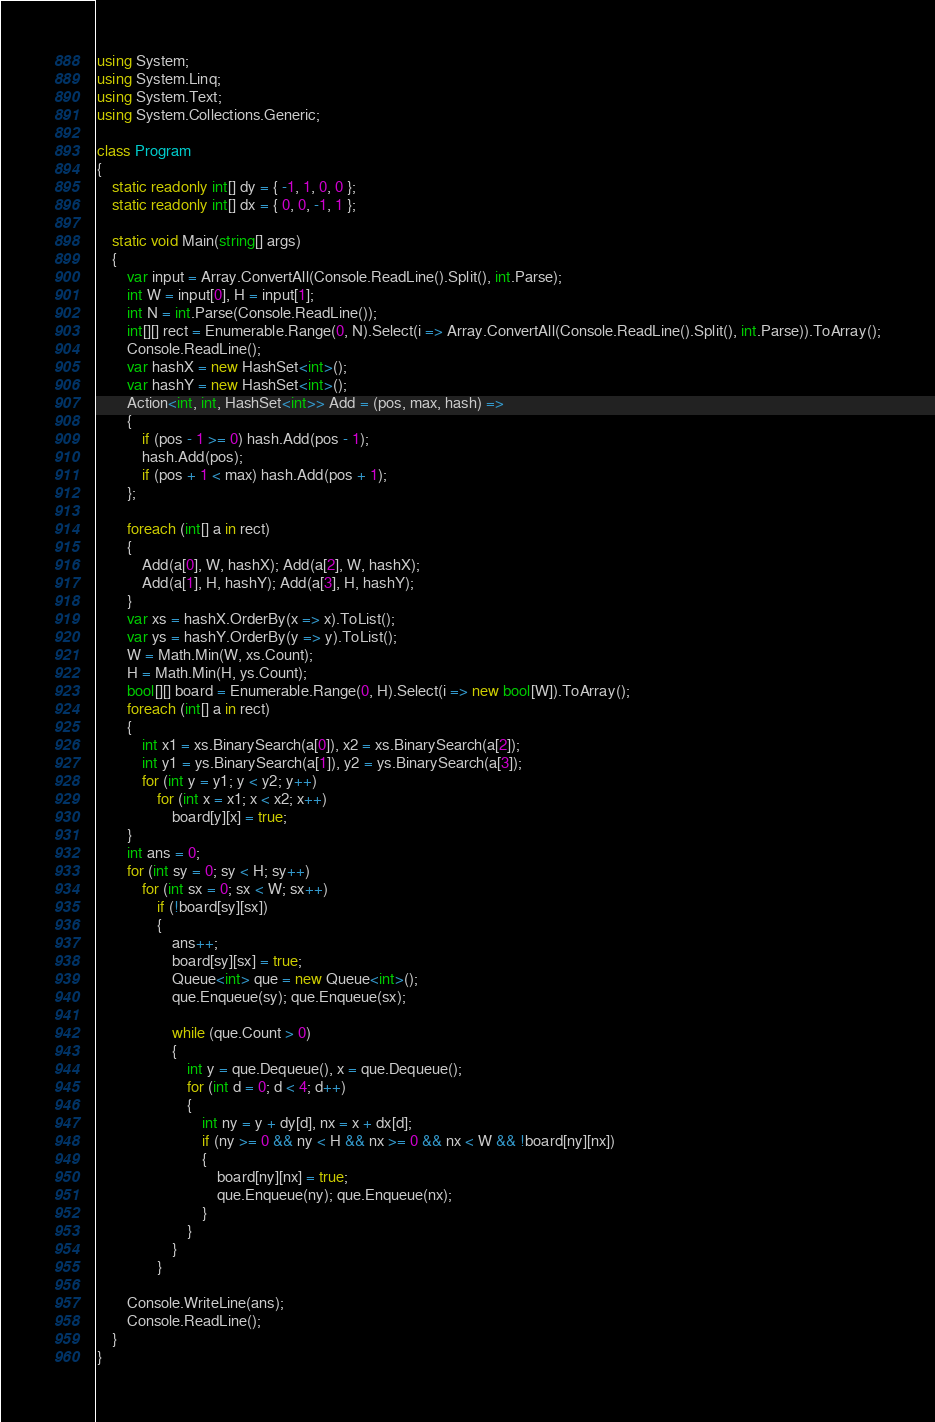<code> <loc_0><loc_0><loc_500><loc_500><_C#_>using System;
using System.Linq;
using System.Text;
using System.Collections.Generic;

class Program
{
    static readonly int[] dy = { -1, 1, 0, 0 };
    static readonly int[] dx = { 0, 0, -1, 1 };

    static void Main(string[] args)
    {
        var input = Array.ConvertAll(Console.ReadLine().Split(), int.Parse);
        int W = input[0], H = input[1];
        int N = int.Parse(Console.ReadLine());
        int[][] rect = Enumerable.Range(0, N).Select(i => Array.ConvertAll(Console.ReadLine().Split(), int.Parse)).ToArray();
        Console.ReadLine();
        var hashX = new HashSet<int>();
        var hashY = new HashSet<int>();
        Action<int, int, HashSet<int>> Add = (pos, max, hash) =>
        {
            if (pos - 1 >= 0) hash.Add(pos - 1);
            hash.Add(pos);
            if (pos + 1 < max) hash.Add(pos + 1);
        };

        foreach (int[] a in rect)
        {
            Add(a[0], W, hashX); Add(a[2], W, hashX);
            Add(a[1], H, hashY); Add(a[3], H, hashY);
        }
        var xs = hashX.OrderBy(x => x).ToList();
        var ys = hashY.OrderBy(y => y).ToList();
        W = Math.Min(W, xs.Count);
        H = Math.Min(H, ys.Count);
        bool[][] board = Enumerable.Range(0, H).Select(i => new bool[W]).ToArray();
        foreach (int[] a in rect)
        {
            int x1 = xs.BinarySearch(a[0]), x2 = xs.BinarySearch(a[2]);
            int y1 = ys.BinarySearch(a[1]), y2 = ys.BinarySearch(a[3]);
            for (int y = y1; y < y2; y++)
                for (int x = x1; x < x2; x++)
                    board[y][x] = true;
        }
        int ans = 0;
        for (int sy = 0; sy < H; sy++)
            for (int sx = 0; sx < W; sx++)
                if (!board[sy][sx])
                {
                    ans++;
                    board[sy][sx] = true;
                    Queue<int> que = new Queue<int>();
                    que.Enqueue(sy); que.Enqueue(sx);

                    while (que.Count > 0)
                    {
                        int y = que.Dequeue(), x = que.Dequeue();
                        for (int d = 0; d < 4; d++)
                        {
                            int ny = y + dy[d], nx = x + dx[d];
                            if (ny >= 0 && ny < H && nx >= 0 && nx < W && !board[ny][nx])
                            {
                                board[ny][nx] = true;
                                que.Enqueue(ny); que.Enqueue(nx);
                            }
                        }
                    }
                }

        Console.WriteLine(ans);
        Console.ReadLine();
    }
}</code> 